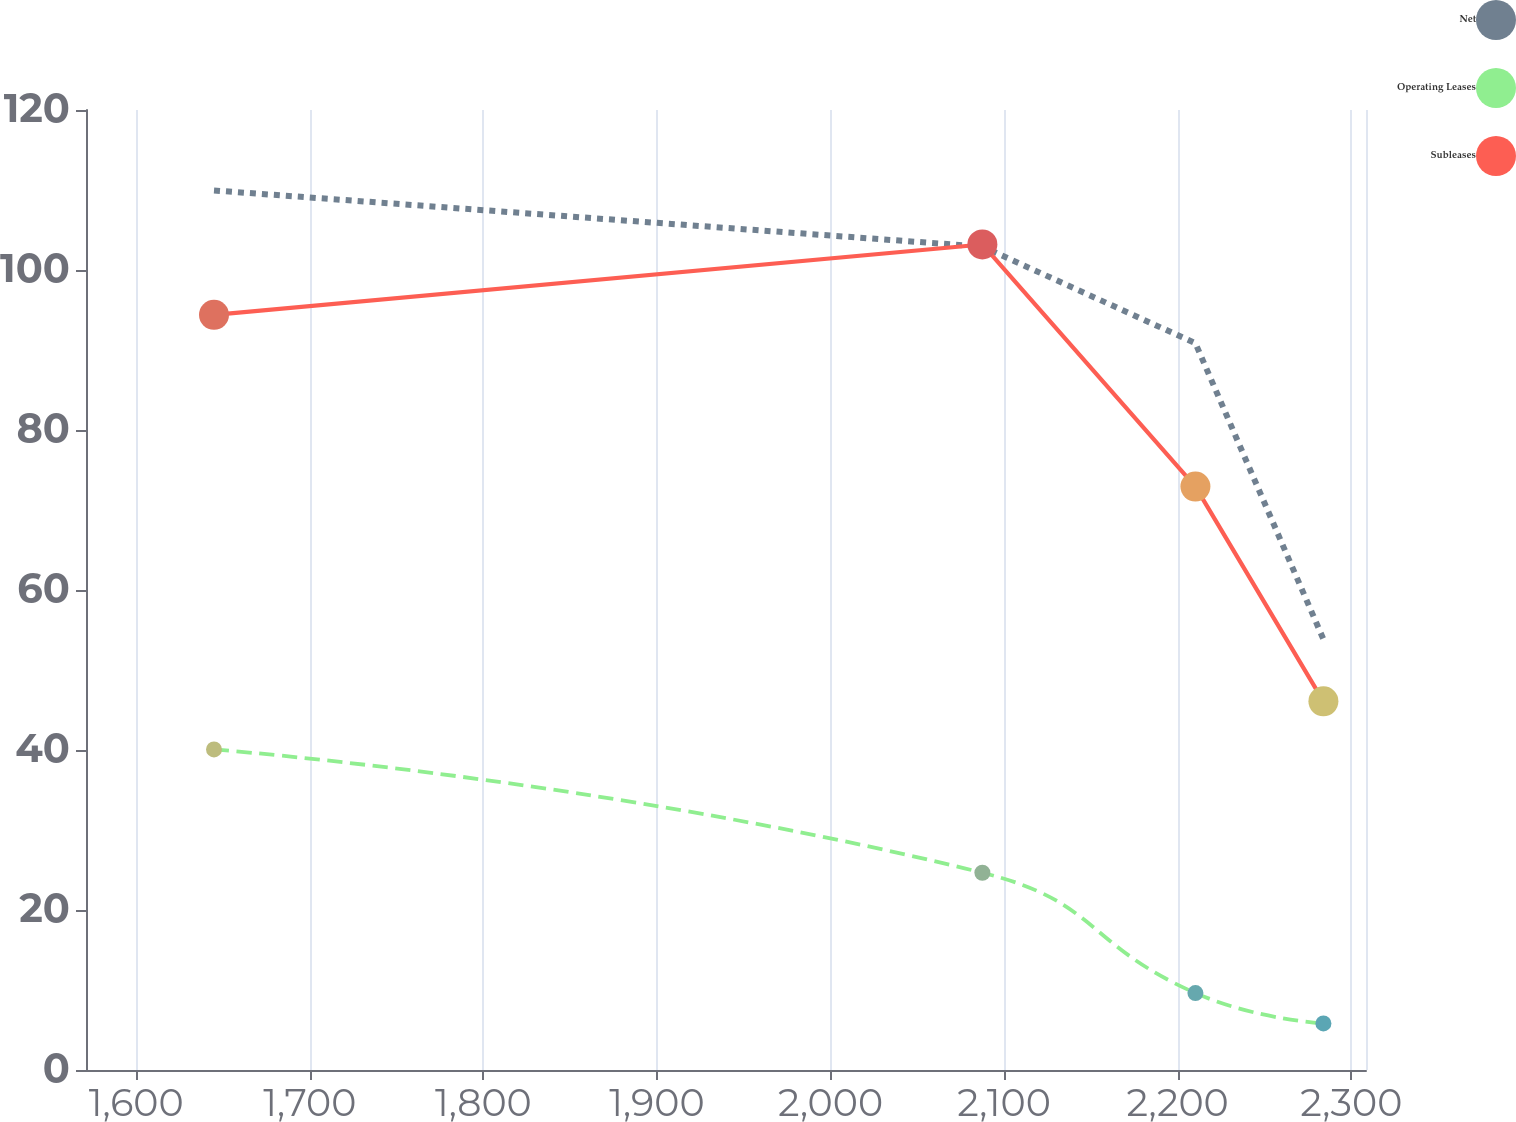Convert chart. <chart><loc_0><loc_0><loc_500><loc_500><line_chart><ecel><fcel>Net<fcel>Operating Leases<fcel>Subleases<nl><fcel>1644.81<fcel>109.94<fcel>40.07<fcel>94.4<nl><fcel>2087.49<fcel>102.92<fcel>24.66<fcel>103.19<nl><fcel>2210.23<fcel>90.85<fcel>9.62<fcel>72.93<nl><fcel>2283.97<fcel>53.85<fcel>5.82<fcel>46.08<nl><fcel>2382.25<fcel>38.41<fcel>2.02<fcel>38.42<nl></chart> 